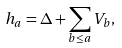Convert formula to latex. <formula><loc_0><loc_0><loc_500><loc_500>h _ { a } = \Delta + \sum _ { b \leq a } V _ { b } ,</formula> 